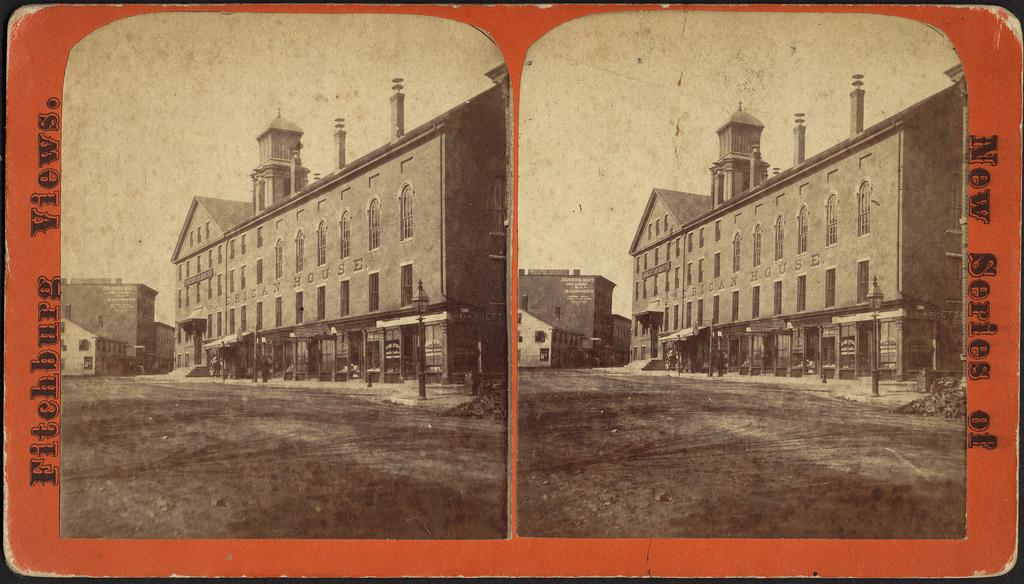How many photos are in the image? There are two black and white photos in the image. What do the photos depict? The photos depict a big building. What is the name of the building? The building is named African house. What is visible at the top of the image? The sky is visible at the top of the image. What color is the ink used to write the name of the building in the image? There is no ink visible in the image, as the name of the building is not written on the photos. 